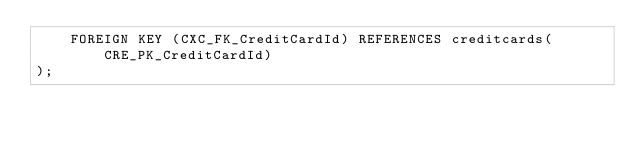<code> <loc_0><loc_0><loc_500><loc_500><_SQL_>    FOREIGN KEY (CXC_FK_CreditCardId) REFERENCES creditcards(CRE_PK_CreditCardId)
);</code> 